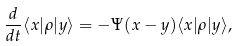<formula> <loc_0><loc_0><loc_500><loc_500>\frac { d } { d t } \langle x | \rho | y \rangle = - \Psi ( x - y ) \langle x | \rho | y \rangle ,</formula> 